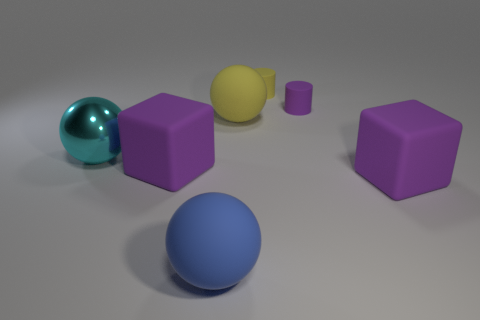Can you speculate on the purpose of this arrangement of objects? Without additional context, it's difficult to determine a definitive purpose. The arrangement could be part of a visual study on geometry, color, texture, or even a basic 3D modeling exercise. 